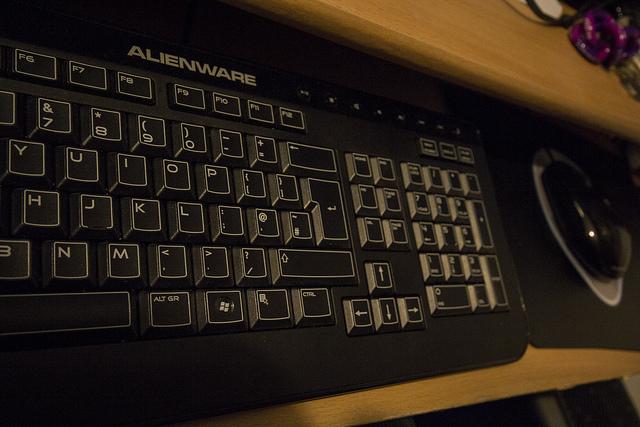Does this keyboard need to be sanitized?
Write a very short answer. No. Is the keyboard laying flat?
Write a very short answer. Yes. What brand is the keyboard?
Keep it brief. Alienware. Is the Q key visible?
Short answer required. No. 